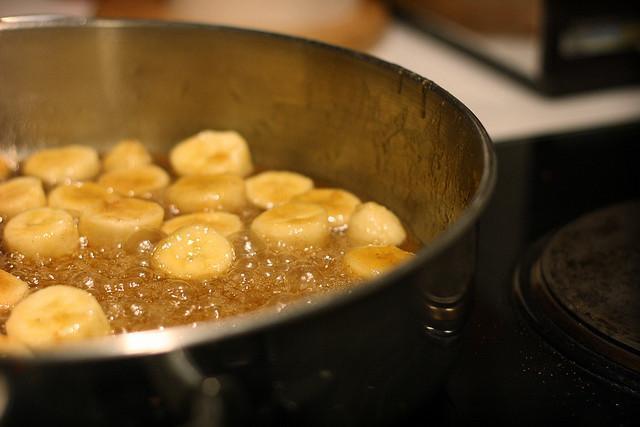What is this pan currently being used to create?
From the following set of four choices, select the accurate answer to respond to the question.
Options: Entree, salad, appetizer, dessert. Dessert. 